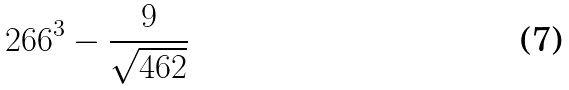<formula> <loc_0><loc_0><loc_500><loc_500>2 6 6 ^ { 3 } - \frac { 9 } { \sqrt { 4 6 2 } }</formula> 